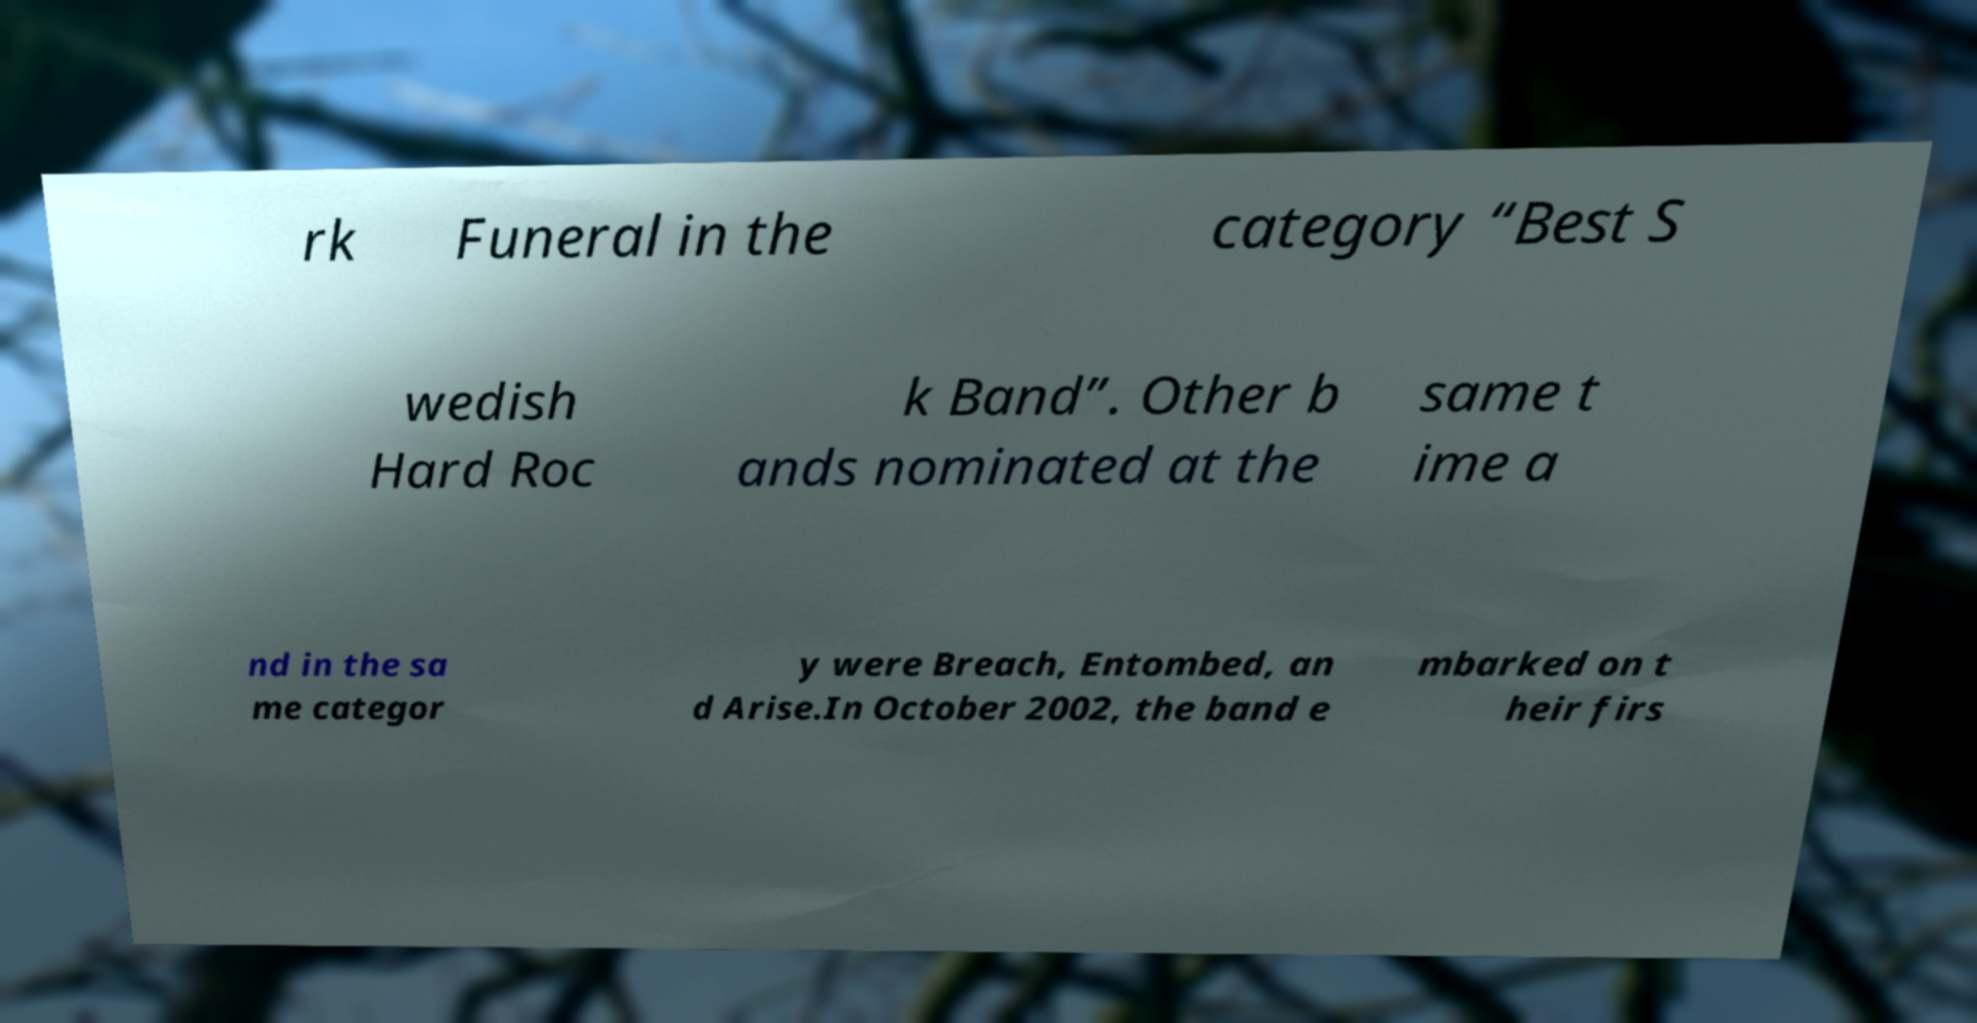Could you extract and type out the text from this image? rk Funeral in the category “Best S wedish Hard Roc k Band”. Other b ands nominated at the same t ime a nd in the sa me categor y were Breach, Entombed, an d Arise.In October 2002, the band e mbarked on t heir firs 